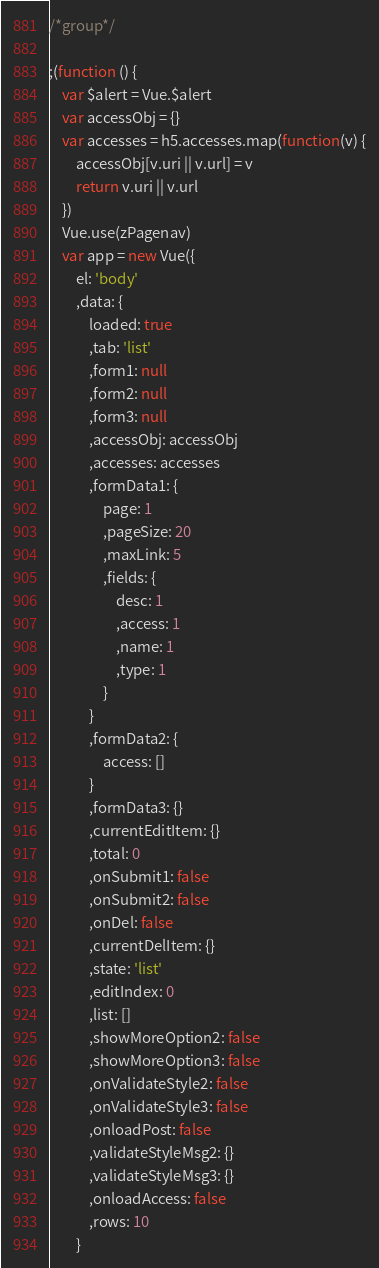Convert code to text. <code><loc_0><loc_0><loc_500><loc_500><_JavaScript_>
/*group*/

;(function () {
	var $alert = Vue.$alert
	var accessObj = {}
	var accesses = h5.accesses.map(function(v) {
		accessObj[v.uri || v.url] = v
		return v.uri || v.url
	})
	Vue.use(zPagenav)
	var app = new Vue({
		el: 'body'
		,data: {
			loaded: true
			,tab: 'list'
			,form1: null
			,form2: null
			,form3: null
			,accessObj: accessObj
			,accesses: accesses
			,formData1: {
				page: 1
				,pageSize: 20
				,maxLink: 5
				,fields: {
					desc: 1
					,access: 1
					,name: 1
					,type: 1
				}
			}
			,formData2: {
				access: []
			}
			,formData3: {}
			,currentEditItem: {}
			,total: 0
			,onSubmit1: false
			,onSubmit2: false
			,onDel: false
			,currentDelItem: {}
			,state: 'list'
			,editIndex: 0
			,list: []
			,showMoreOption2: false
			,showMoreOption3: false
			,onValidateStyle2: false
			,onValidateStyle3: false
			,onloadPost: false
			,validateStyleMsg2: {}
			,validateStyleMsg3: {}
			,onloadAccess: false
			,rows: 10
		}</code> 